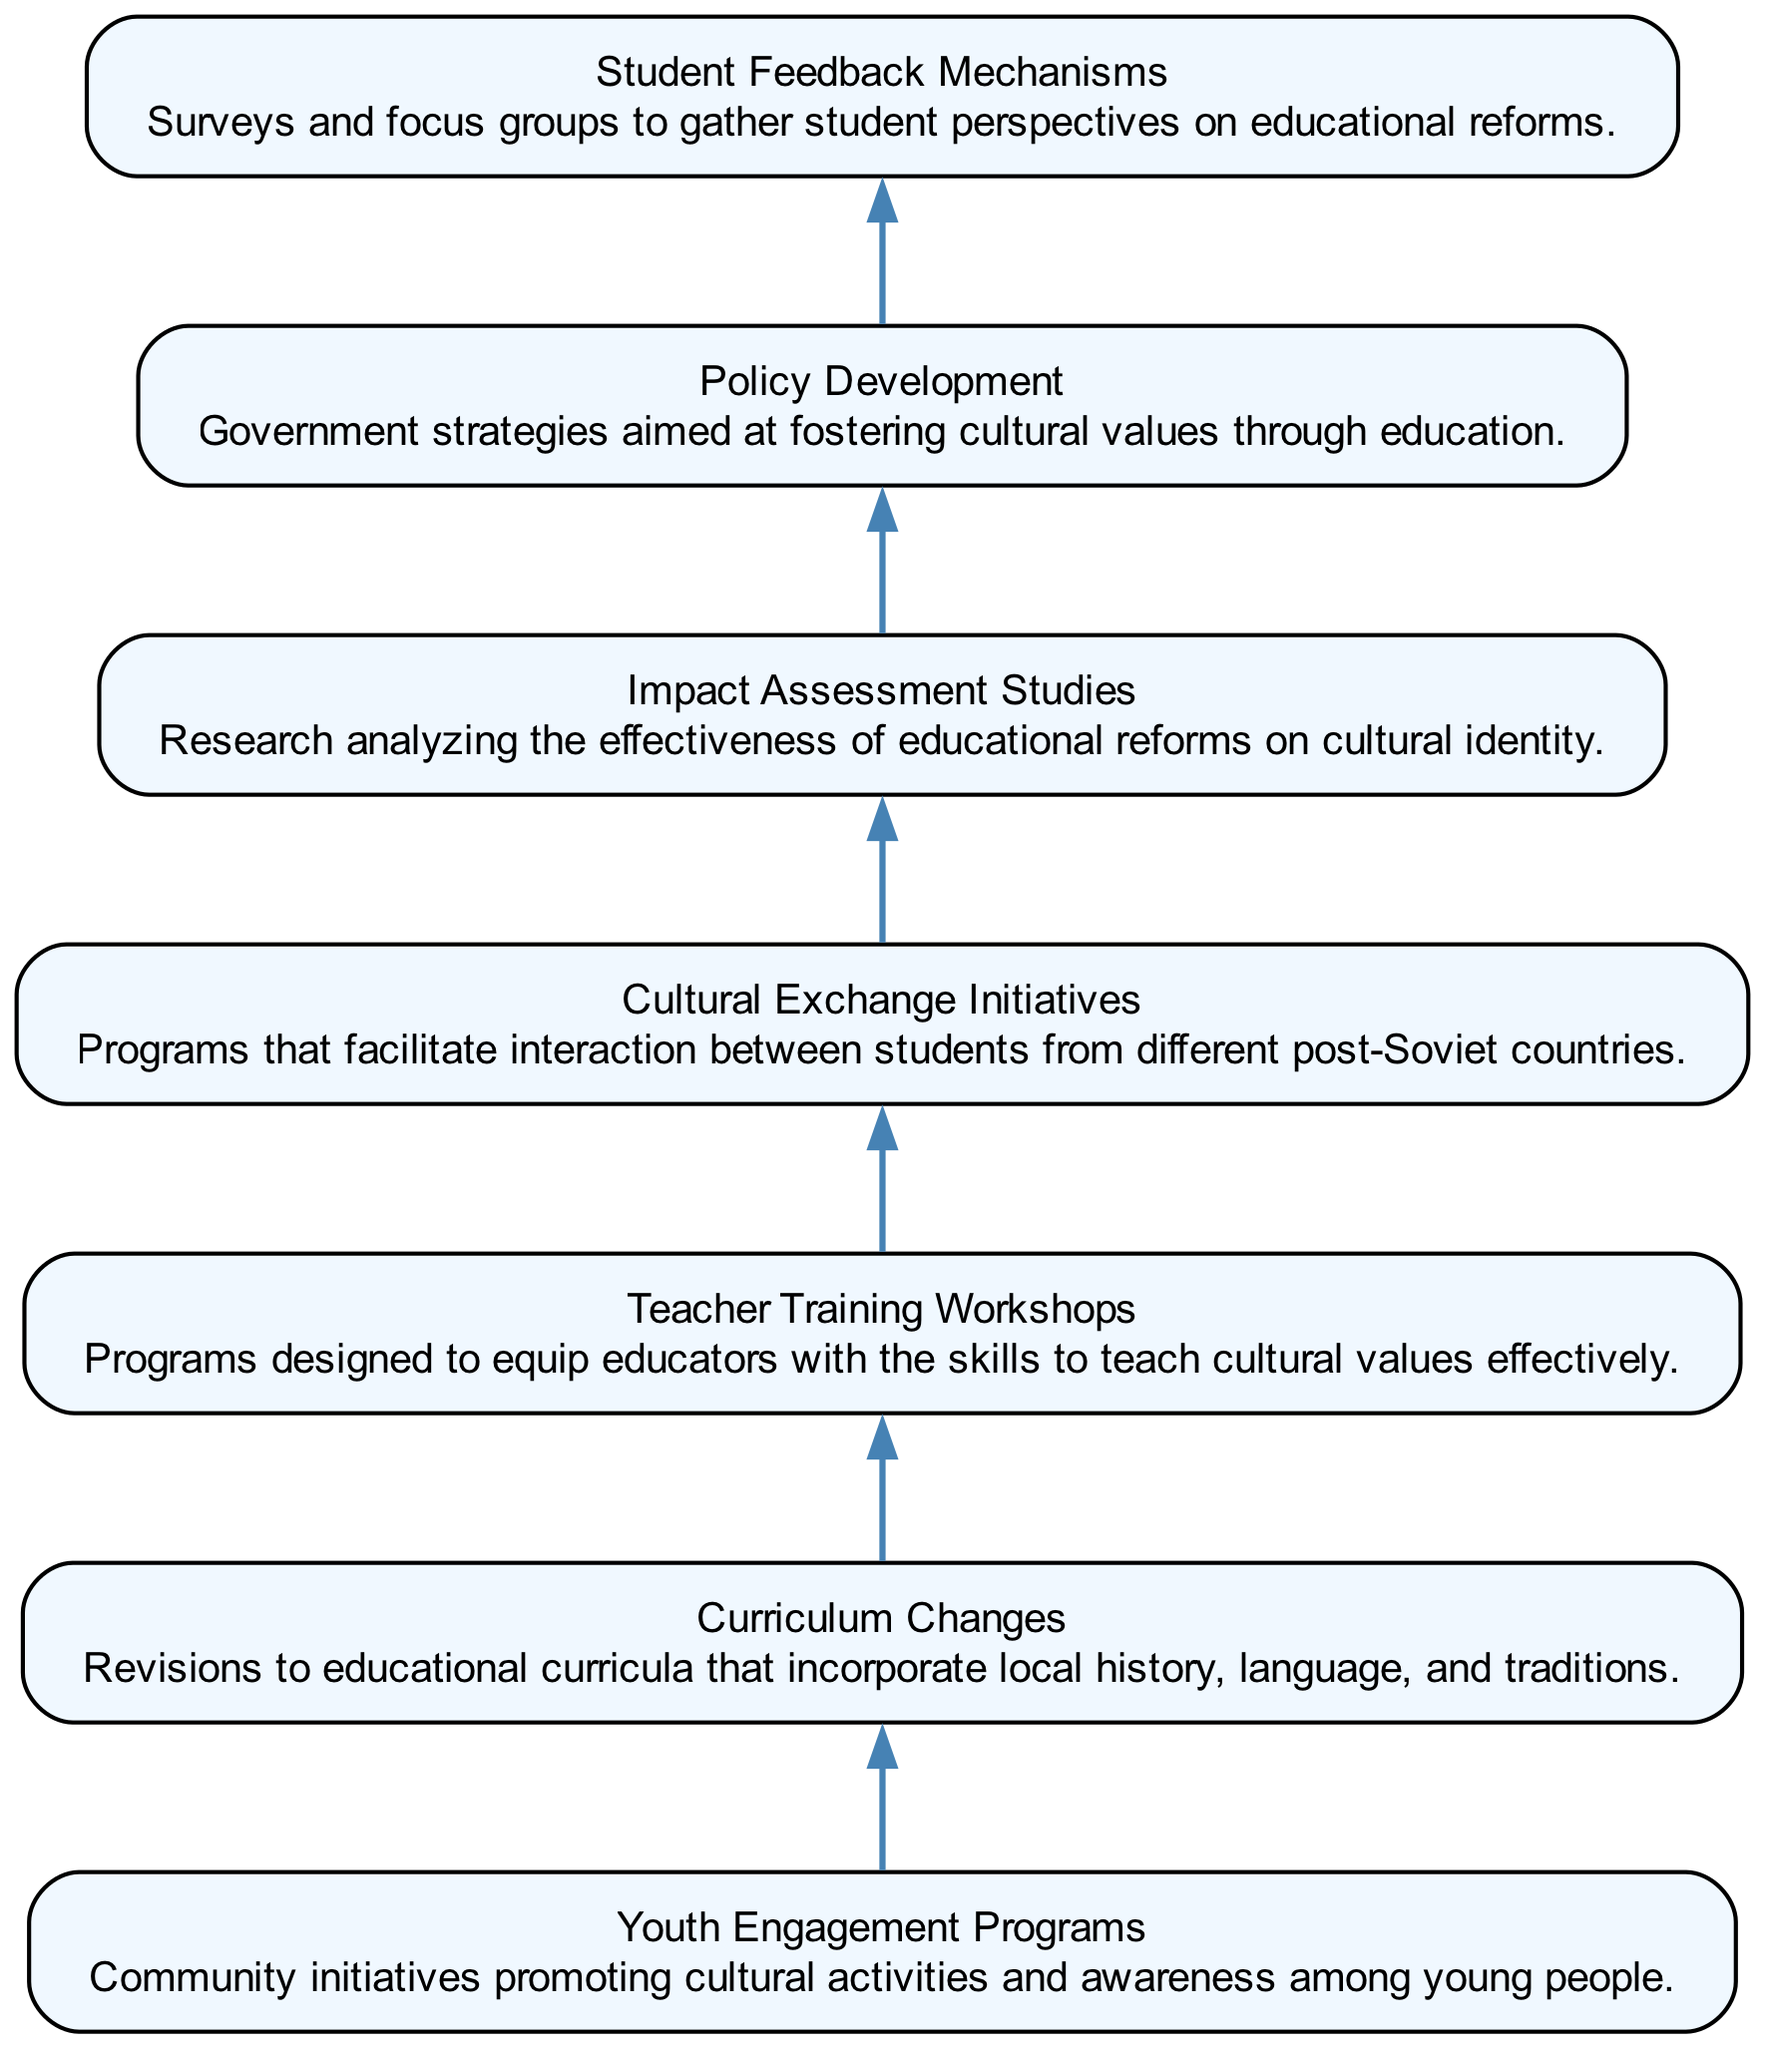What is the title of the first node? The first node in the diagram is labeled "Youth Engagement Programs," which is explicitly stated at the top of the first rectangular box.
Answer: Youth Engagement Programs How many nodes are present in the diagram? By counting the rectangular boxes in the diagram, we can identify that there are 7 distinct nodes or elements present, each representing a different aspect of the educational reforms and cultural engagement.
Answer: 7 What is the relationship between node 2 and node 3? Node 2 titled "Curriculum Changes" connects to node 3 titled "Teacher Training Workshops," indicating that changes in curriculum prompt the need for workshops to train teachers in delivering that revised curriculum effectively.
Answer: Curriculum Changes → Teacher Training Workshops Which node deals with assessing the effectiveness of educational reforms? The node that focuses on the evaluation of educational reforms' impact on cultural identity is labeled "Impact Assessment Studies," which specifically addresses the need to research and analyze these effects.
Answer: Impact Assessment Studies What is the title of the last node? The last node in the flow chart is labeled "Student Feedback Mechanisms," which reflects the importance of incorporating student perspectives in understanding the effects of educational reforms.
Answer: Student Feedback Mechanisms Which two nodes are associated with training and development? The nodes linked to training and development are "Teacher Training Workshops" (Node 3) and "Policy Development" (Node 6), indicating that both are essential for better educational practices and fostering cultural values through education.
Answer: Teacher Training Workshops, Policy Development What is the purpose of node 4? Node 4, titled "Cultural Exchange Initiatives," focuses on promoting interaction and collaboration among students from different post-Soviet countries, helping to enhance cultural understanding and identity among the youth.
Answer: Cultural Exchange Initiatives How do "Youth Engagement Programs" influence "Policy Development"? "Youth Engagement Programs" likely provide insights and feedback that inform "Policy Development" in terms of what cultural values and engagement methods resonate with the youth, thus shaping meaningful government strategies for education.
Answer: Feedback for Policy Development 